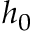Convert formula to latex. <formula><loc_0><loc_0><loc_500><loc_500>h _ { 0 }</formula> 